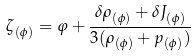<formula> <loc_0><loc_0><loc_500><loc_500>\zeta _ { ( \phi ) } = \varphi + \frac { \delta \rho _ { ( \phi ) } + \delta J _ { ( \phi ) } } { 3 ( \rho _ { ( \phi ) } + p _ { ( \phi ) } ) }</formula> 